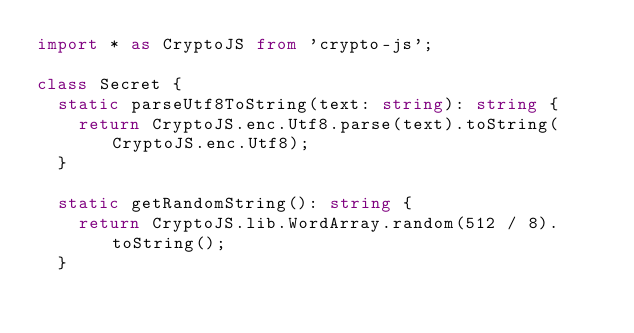Convert code to text. <code><loc_0><loc_0><loc_500><loc_500><_TypeScript_>import * as CryptoJS from 'crypto-js';

class Secret {
  static parseUtf8ToString(text: string): string {
    return CryptoJS.enc.Utf8.parse(text).toString(CryptoJS.enc.Utf8);
  }

  static getRandomString(): string {
    return CryptoJS.lib.WordArray.random(512 / 8).toString();
  }
</code> 